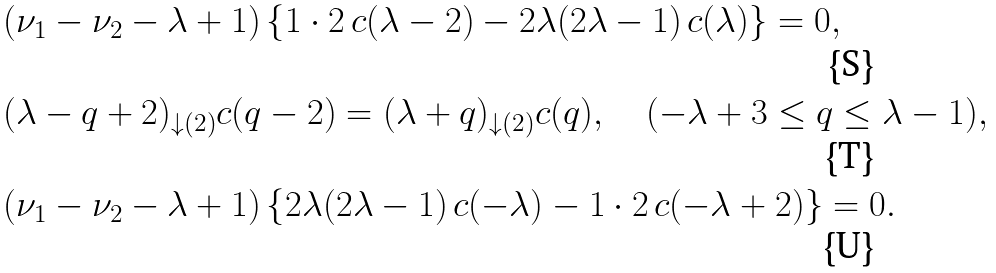<formula> <loc_0><loc_0><loc_500><loc_500>& ( \nu _ { 1 } - \nu _ { 2 } - \lambda + 1 ) \left \{ 1 \cdot 2 \, c ( \lambda - 2 ) - 2 \lambda ( 2 \lambda - 1 ) \, c ( \lambda ) \right \} = 0 , \\ & ( \lambda - q + 2 ) _ { \downarrow ( 2 ) } c ( q - 2 ) = ( \lambda + q ) _ { \downarrow ( 2 ) } c ( q ) , \quad ( - \lambda + 3 \leq q \leq \lambda - 1 ) , \\ & ( \nu _ { 1 } - \nu _ { 2 } - \lambda + 1 ) \left \{ 2 \lambda ( 2 \lambda - 1 ) \, c ( - \lambda ) - 1 \cdot 2 \, c ( - \lambda + 2 ) \right \} = 0 .</formula> 